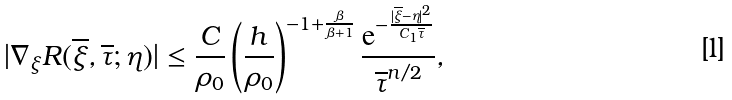<formula> <loc_0><loc_0><loc_500><loc_500>| \nabla _ { \xi } R ( \overline { \xi } , \overline { \tau } ; \eta ) | \leq \frac { C } { \rho _ { 0 } } \left ( \frac { h } { \rho _ { 0 } } \right ) ^ { - 1 + \frac { \beta } { \beta + 1 } } \frac { \mathrm e ^ { - \frac { | \overline { \xi } - \eta | ^ { 2 } } { C _ { 1 } \overline { \tau } } } } { \overline { \tau } ^ { n / 2 } } ,</formula> 